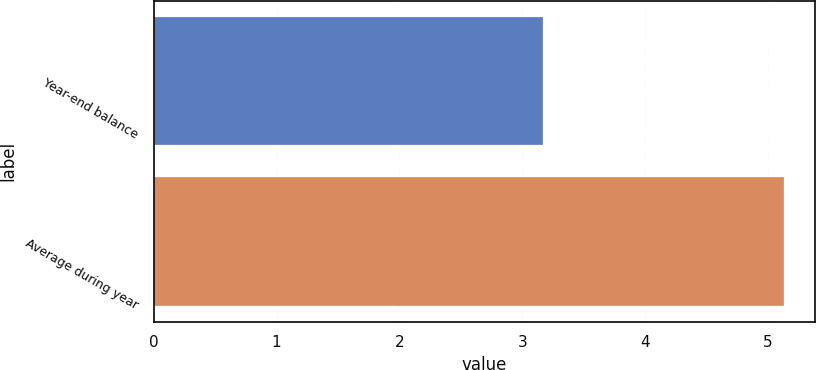<chart> <loc_0><loc_0><loc_500><loc_500><bar_chart><fcel>Year-end balance<fcel>Average during year<nl><fcel>3.17<fcel>5.13<nl></chart> 